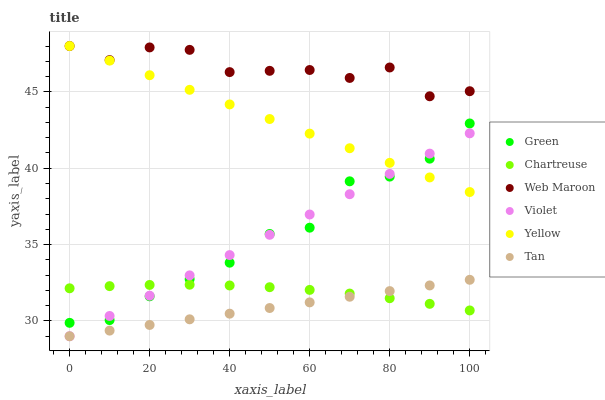Does Tan have the minimum area under the curve?
Answer yes or no. Yes. Does Web Maroon have the maximum area under the curve?
Answer yes or no. Yes. Does Yellow have the minimum area under the curve?
Answer yes or no. No. Does Yellow have the maximum area under the curve?
Answer yes or no. No. Is Tan the smoothest?
Answer yes or no. Yes. Is Web Maroon the roughest?
Answer yes or no. Yes. Is Yellow the smoothest?
Answer yes or no. No. Is Yellow the roughest?
Answer yes or no. No. Does Violet have the lowest value?
Answer yes or no. Yes. Does Yellow have the lowest value?
Answer yes or no. No. Does Yellow have the highest value?
Answer yes or no. Yes. Does Chartreuse have the highest value?
Answer yes or no. No. Is Green less than Web Maroon?
Answer yes or no. Yes. Is Web Maroon greater than Green?
Answer yes or no. Yes. Does Green intersect Violet?
Answer yes or no. Yes. Is Green less than Violet?
Answer yes or no. No. Is Green greater than Violet?
Answer yes or no. No. Does Green intersect Web Maroon?
Answer yes or no. No. 